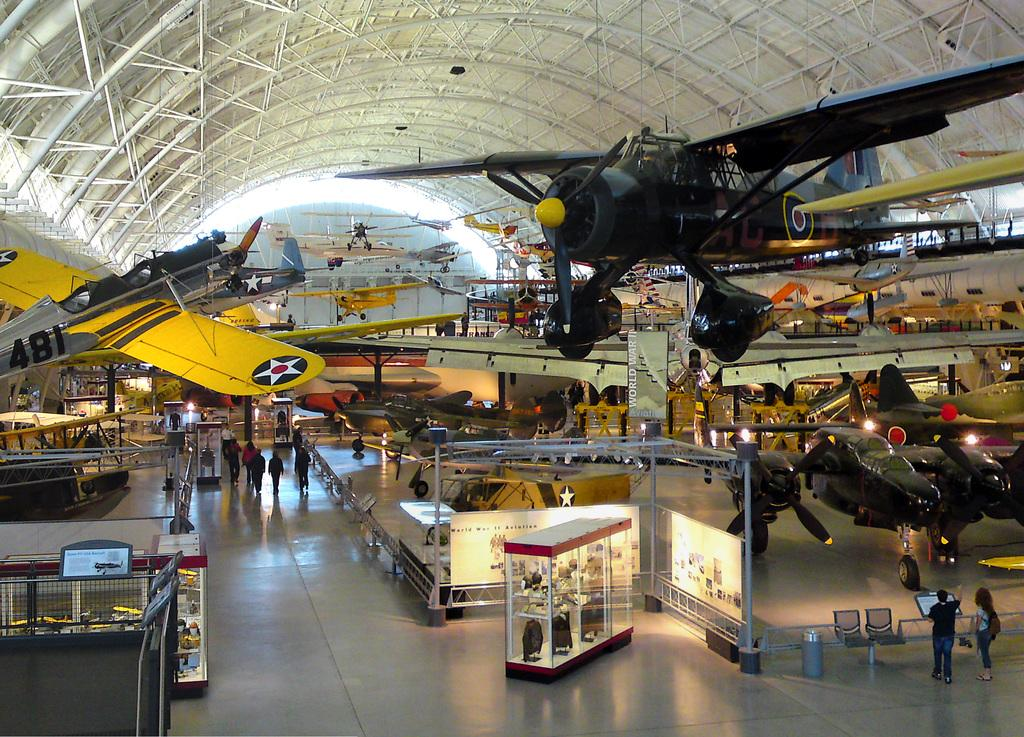<image>
Summarize the visual content of the image. Some planes indoors, one of which has the number 481 on it. 